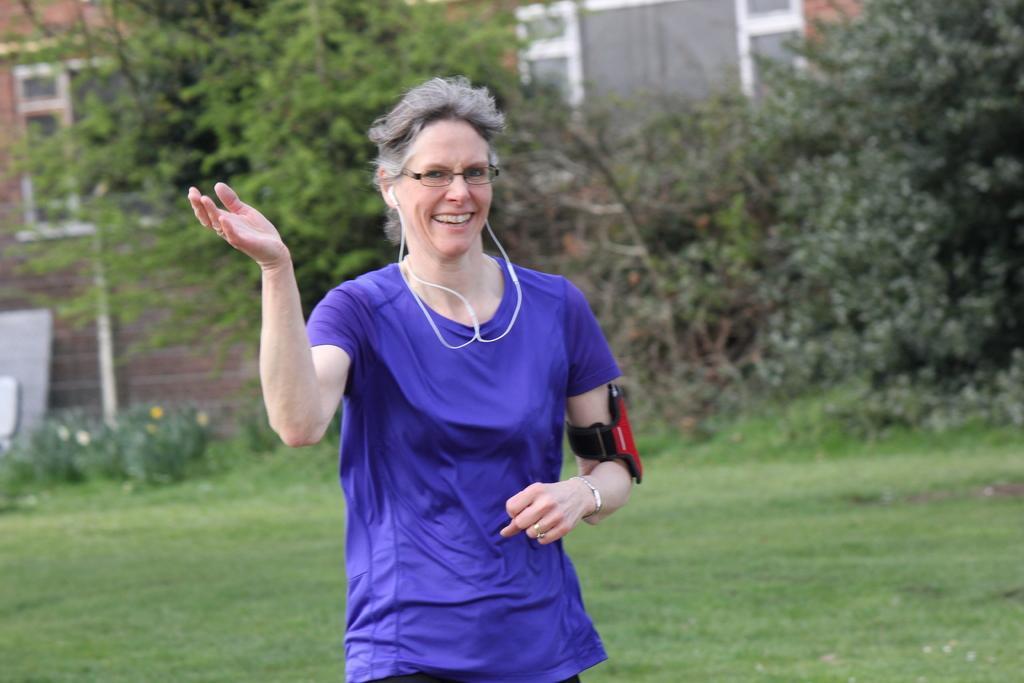Please provide a concise description of this image. In the center of the image we can see a lady standing and smiling. In the background there are buildings, trees and grass. 